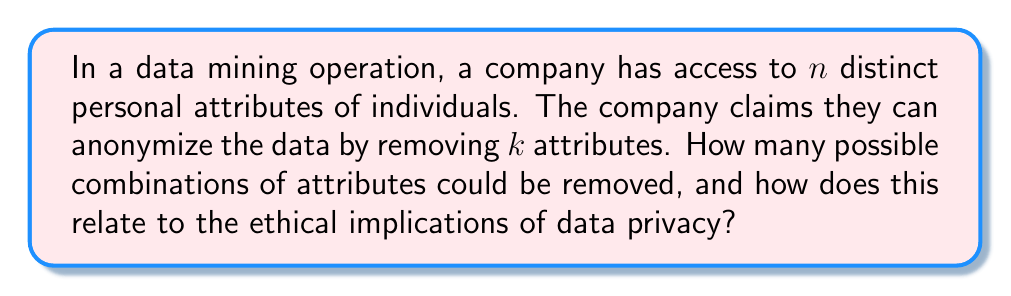What is the answer to this math problem? Step 1: Understand the combinatorial problem
We need to calculate the number of ways to choose $k$ attributes from $n$ total attributes. This is a combination problem, denoted as $\binom{n}{k}$ or $C(n,k)$.

Step 2: Apply the combination formula
The number of combinations is given by:

$$\binom{n}{k} = \frac{n!}{k!(n-k)!}$$

Step 3: Interpret the result
This number represents the total possible ways the company could choose to remove $k$ attributes from $n$ total attributes.

Step 4: Ethical considerations
From a philosophical standpoint, this mathematical approach to privacy raises several ethical concerns:

a) The sheer number of combinations suggests a mechanistic view of personal data, reducing human complexity to mere permutations.

b) The illusion of anonymity: Even with $k$ attributes removed, the remaining $(n-k)$ attributes may still be sufficient to identify individuals.

c) The quantification of privacy: By reducing privacy to a mathematical problem, we risk overlooking the qualitative, human aspects of privacy.

d) Ethical responsibility: The large number of combinations might be used as an excuse for companies to claim they've done due diligence, without considering the real-world implications of their choices.

e) Consent and autonomy: This approach doesn't account for individual preferences regarding which attributes are more sensitive or important to protect.

Step 5: Philosophical critique
As philosophers, we must question whether this logical, combinatorial approach truly captures the essence of privacy and ethical data handling. The reduction of human identity to a set of attributes that can be mathematically manipulated fails to acknowledge the intrinsic value and dignity of human beings.
Answer: $\binom{n}{k}$ combinations; ethically problematic 